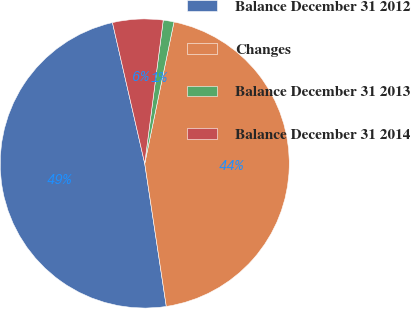Convert chart. <chart><loc_0><loc_0><loc_500><loc_500><pie_chart><fcel>Balance December 31 2012<fcel>Changes<fcel>Balance December 31 2013<fcel>Balance December 31 2014<nl><fcel>48.8%<fcel>44.37%<fcel>1.2%<fcel>5.63%<nl></chart> 